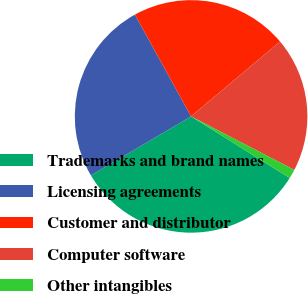Convert chart. <chart><loc_0><loc_0><loc_500><loc_500><pie_chart><fcel>Trademarks and brand names<fcel>Licensing agreements<fcel>Customer and distributor<fcel>Computer software<fcel>Other intangibles<nl><fcel>32.65%<fcel>25.44%<fcel>21.89%<fcel>18.75%<fcel>1.27%<nl></chart> 